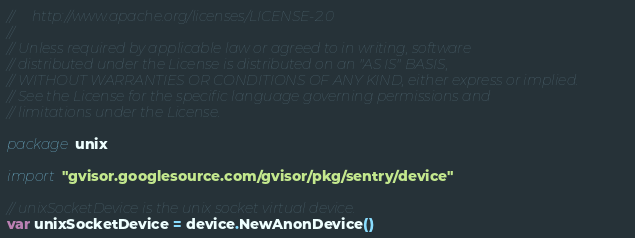<code> <loc_0><loc_0><loc_500><loc_500><_Go_>//     http://www.apache.org/licenses/LICENSE-2.0
//
// Unless required by applicable law or agreed to in writing, software
// distributed under the License is distributed on an "AS IS" BASIS,
// WITHOUT WARRANTIES OR CONDITIONS OF ANY KIND, either express or implied.
// See the License for the specific language governing permissions and
// limitations under the License.

package unix

import "gvisor.googlesource.com/gvisor/pkg/sentry/device"

// unixSocketDevice is the unix socket virtual device.
var unixSocketDevice = device.NewAnonDevice()
</code> 